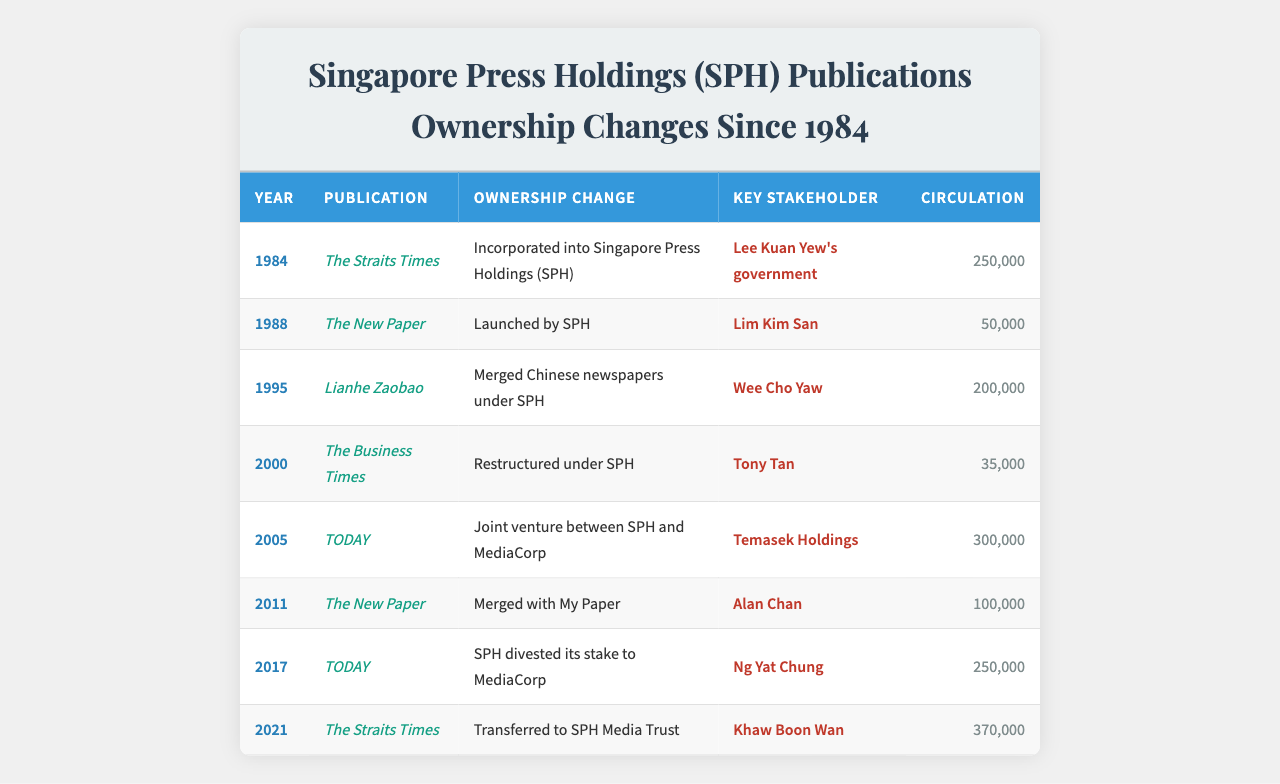What year was The Straits Times incorporated into SPH? The table shows that The Straits Times was incorporated into Singapore Press Holdings (SPH) in 1984.
Answer: 1984 What was the circulation of The New Paper when it was launched? According to the table, The New Paper had a circulation of 50,000 when it was launched by SPH in 1988.
Answer: 50,000 Which publication had the highest circulation in 2021? The Straits Times had the highest circulation of 370,000 in 2021 as per the data in the table.
Answer: The Straits Times How many publications underwent ownership changes in the year 2005? The table indicates that only one publication, TODAY, underwent an ownership change in 2005.
Answer: 1 Was Lianhe Zaobao ever merged with another publication? The table states that Lianhe Zaobao merged Chinese newspapers under SPH, which indicates a merger.
Answer: Yes What publication had the highest circulation at any given time before 2017? To find this, we review the circulations: 250,000 (The Straits Times, 1984), 500,000 (The New Paper, 1988), 200,000 (Lianhe Zaobao, 1995), and 350,000 (The Business Times, 2000). The highest is 250,000 from The Straits Times.
Answer: The Straits Times How many times did The New Paper change ownership between 1988 and 2011? The New Paper changed ownership twice: first launched in 1988 and then merged with My Paper in 2011.
Answer: 2 What was the total circulation of the publications listed in 2000? In 2000, The Business Times had a circulation of 35,000. Since it is the only publication listed for that year, the total circulation is 35,000.
Answer: 35,000 Which publication saw MediaCorp taking a larger control due to SPH's divestment in 2017? The table shows that in 2017, MediaCorp took full control of TODAY when SPH divested its stake.
Answer: TODAY What was the difference in circulation between The New Paper in 1988 and 2011? The New Paper had a circulation of 50,000 in 1988 and 100,000 in 2011. The difference is 100,000 - 50,000 = 50,000.
Answer: 50,000 What trend can be inferred about the ownership of SPH publications between 1984 and 2021? The data indicates that SPH started as a government-operated press and over the years shows multiple ownership changes, indicating a trend towards diversification and investment in partnerships or divestment.
Answer: Diversification and partnership investments 